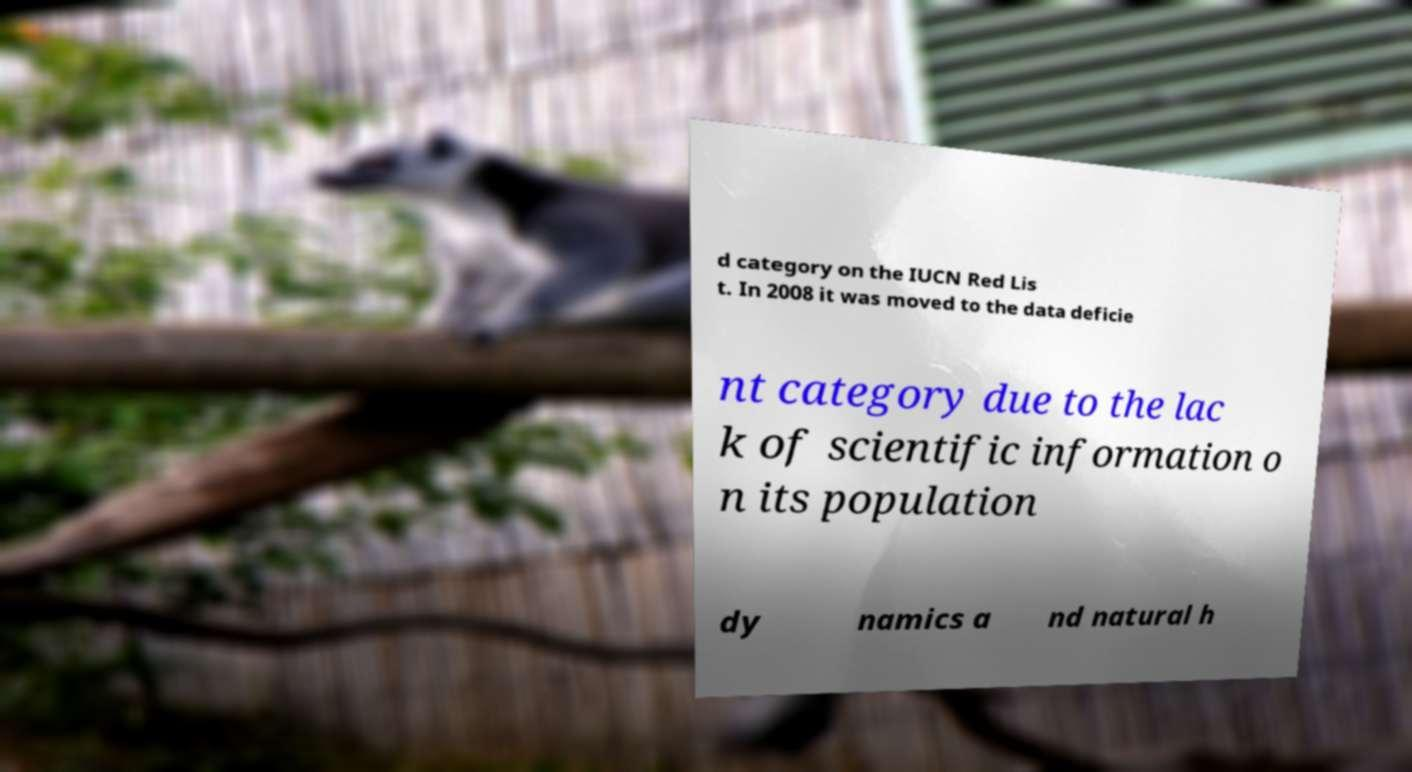What messages or text are displayed in this image? I need them in a readable, typed format. d category on the IUCN Red Lis t. In 2008 it was moved to the data deficie nt category due to the lac k of scientific information o n its population dy namics a nd natural h 